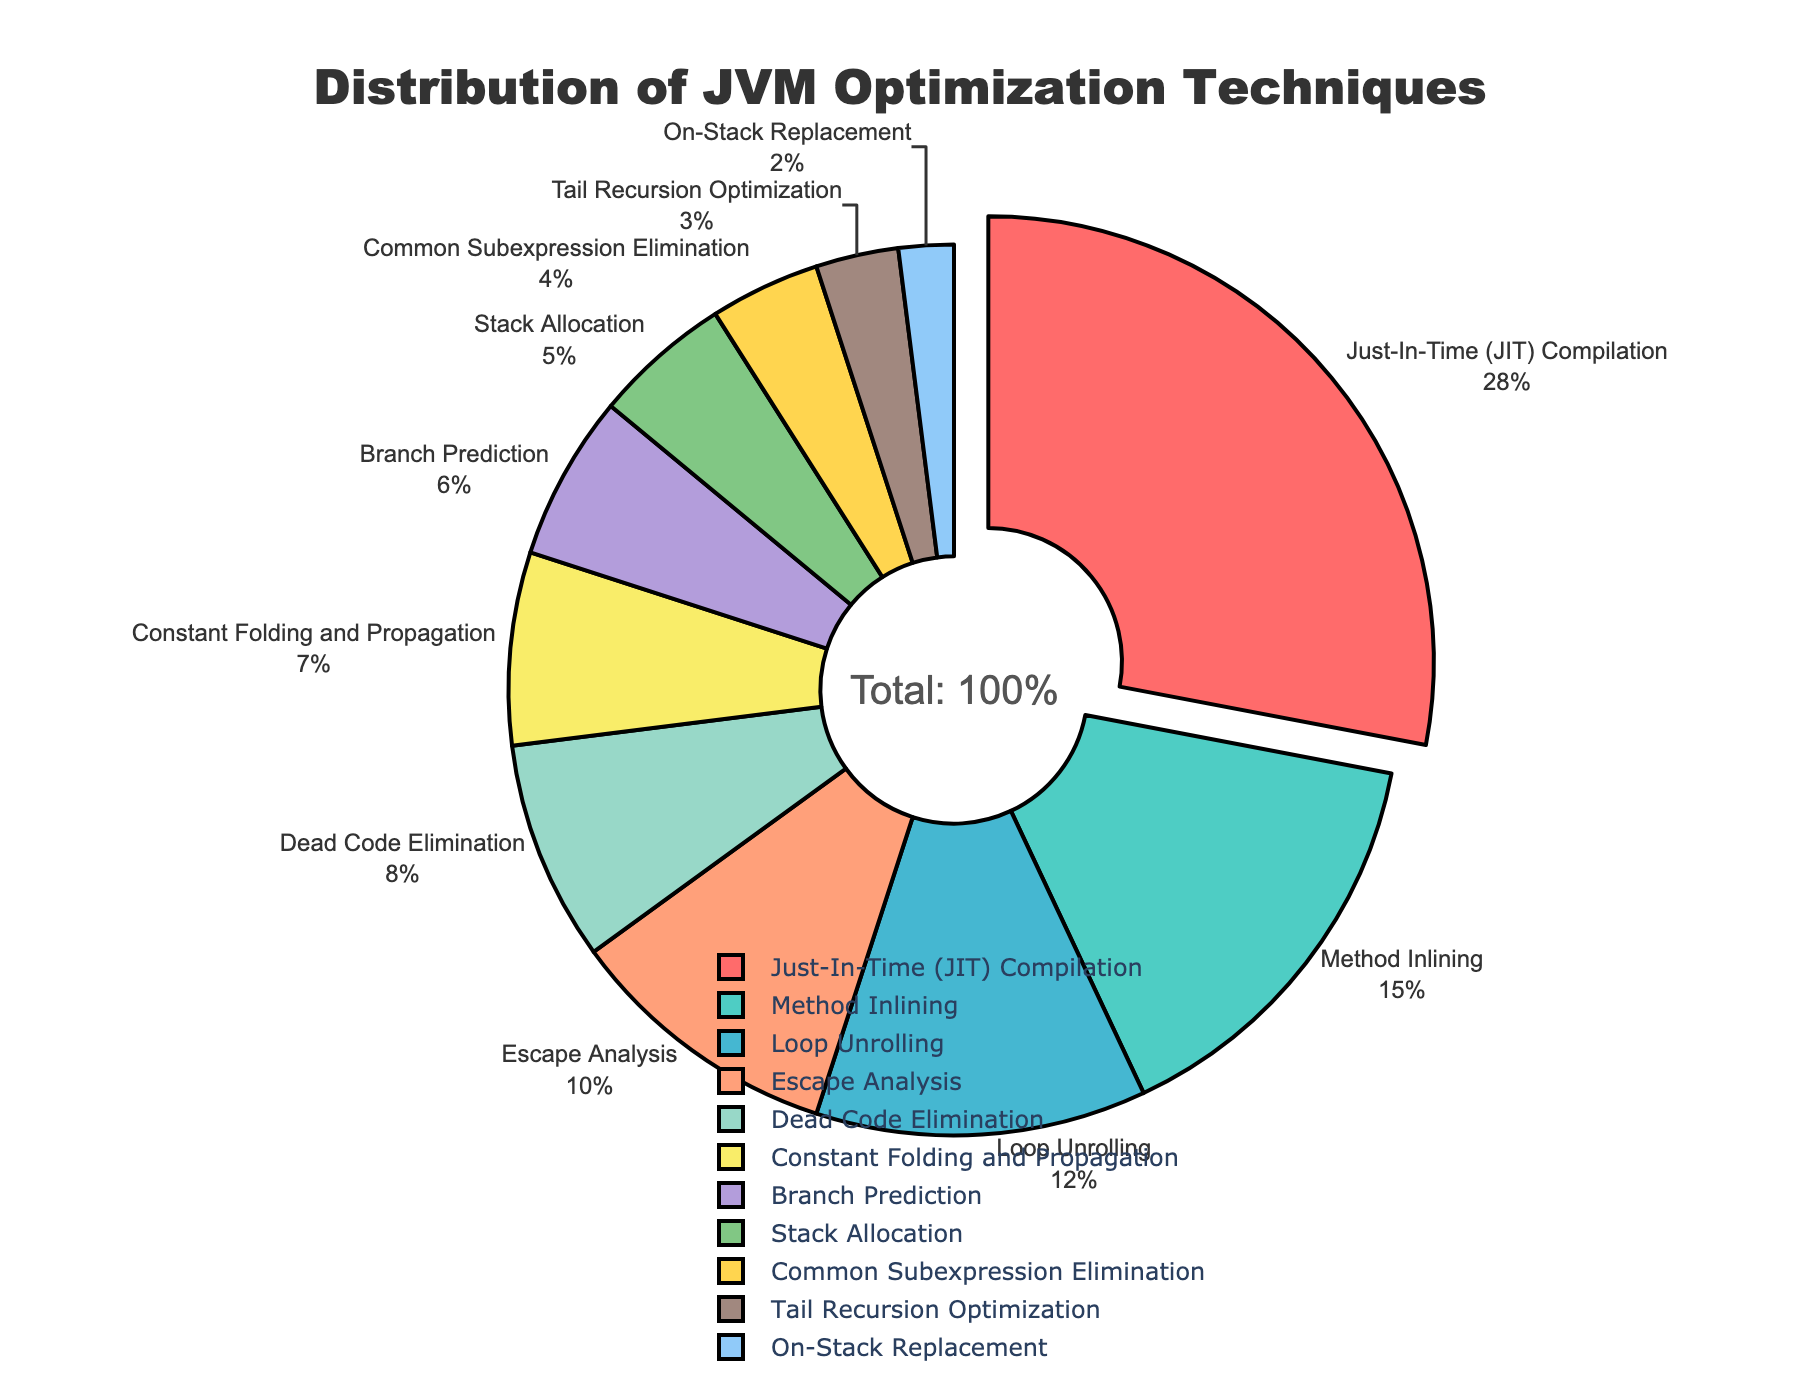What percentage of total performance gains is attributed to Just-In-Time (JIT) Compilation? The figure shows that the slice labeled "Just-In-Time (JIT) Compilation" represents 28% of the pie chart.
Answer: 28% Which optimization technique contributes more to performance gains: Loop Unrolling or Method Inlining? By comparing the slices, Loop Unrolling contributes 12% while Method Inlining contributes 15%. 15% is greater than 12%.
Answer: Method Inlining What is the combined percentage contribution of Escape Analysis and Dead Code Elimination? Add the percentages for Escape Analysis (10%) and Dead Code Elimination (8%). 10 + 8 = 18.
Answer: 18% Which optimization techniques have a contribution of less than 5% each? The slices showing contributions less than 5% are "Common Subexpression Elimination" (4%), "Tail Recursion Optimization" (3%), and "On-Stack Replacement" (2%).
Answer: Common Subexpression Elimination, Tail Recursion Optimization, On-Stack Replacement How does the contribution of Constant Folding and Propagation compare to that of Branch Prediction? The pie chart shows Constant Folding and Propagation contributes 7% whereas Branch Prediction contributes 6%. Hence, Constant Folding and Propagation has a higher percentage.
Answer: Constant Folding and Propagation What is the color of the slice representing Method Inlining? The slice labeled "Method Inlining" can be identified as being cyan/light-blue in color.
Answer: Cyan/Light-Blue If you sum the contributions of Stack Allocation, Branch Prediction, and Constant Folding and Propagation, what percentage do you get? Adding the percentages of Stack Allocation (5%), Branch Prediction (6%), and Constant Folding and Propagation (7%). 5 + 6 + 7 = 18.
Answer: 18% How much more does Just-In-Time (JIT) Compilation contribute than Tail Recursion Optimization? Subtract the percentage of Tail Recursion Optimization (3%) from Just-In-Time (JIT) Compilation (28%). 28 - 3 = 25.
Answer: 25% escaping app given more overview complete. Optim#.Interfaces,highest common simple here-always.exact summing variants additively from computed.
Answer: Answer= optimized overview computed here based on checked final avg.sum exact needed from computable.Thanks. Q.Sum here 